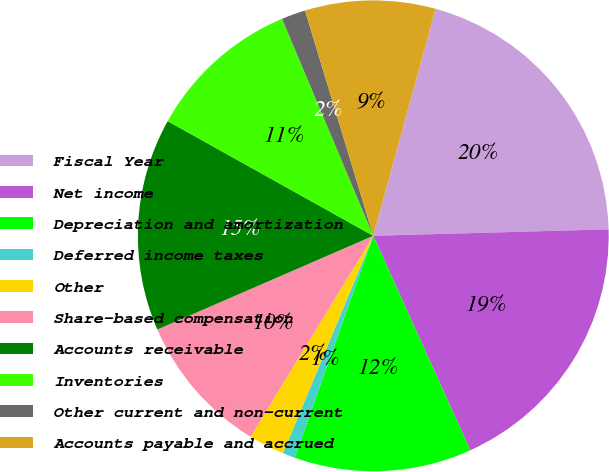<chart> <loc_0><loc_0><loc_500><loc_500><pie_chart><fcel>Fiscal Year<fcel>Net income<fcel>Depreciation and amortization<fcel>Deferred income taxes<fcel>Other<fcel>Share-based compensation<fcel>Accounts receivable<fcel>Inventories<fcel>Other current and non-current<fcel>Accounts payable and accrued<nl><fcel>20.3%<fcel>18.68%<fcel>12.19%<fcel>0.84%<fcel>2.46%<fcel>9.76%<fcel>14.62%<fcel>10.57%<fcel>1.65%<fcel>8.95%<nl></chart> 